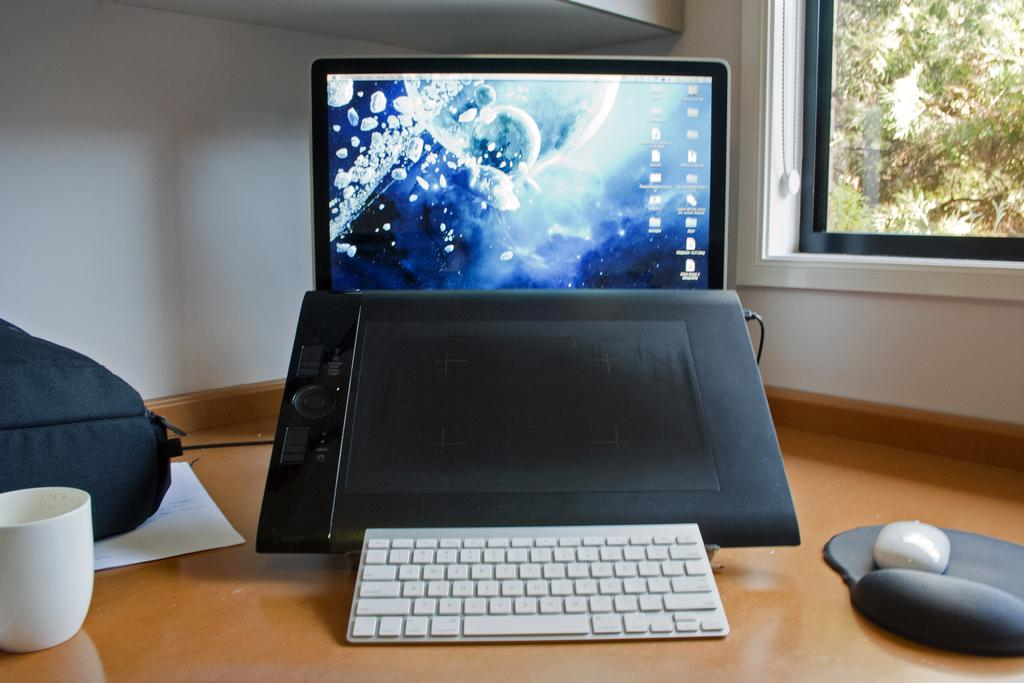What is the main object in the middle of the image? There is a laptop in the middle of the image. What can be seen on the left side of the image? There is a cup on the left side of the image. What type of architectural feature is on the right side of the image? There is a glass window on the right side of the image. What type of scarf is draped over the laptop in the image? There is no scarf present in the image; the laptop is not covered by any fabric. 